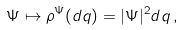<formula> <loc_0><loc_0><loc_500><loc_500>\Psi \mapsto \rho ^ { \Psi } ( d q ) = | \Psi | ^ { 2 } d q \, ,</formula> 